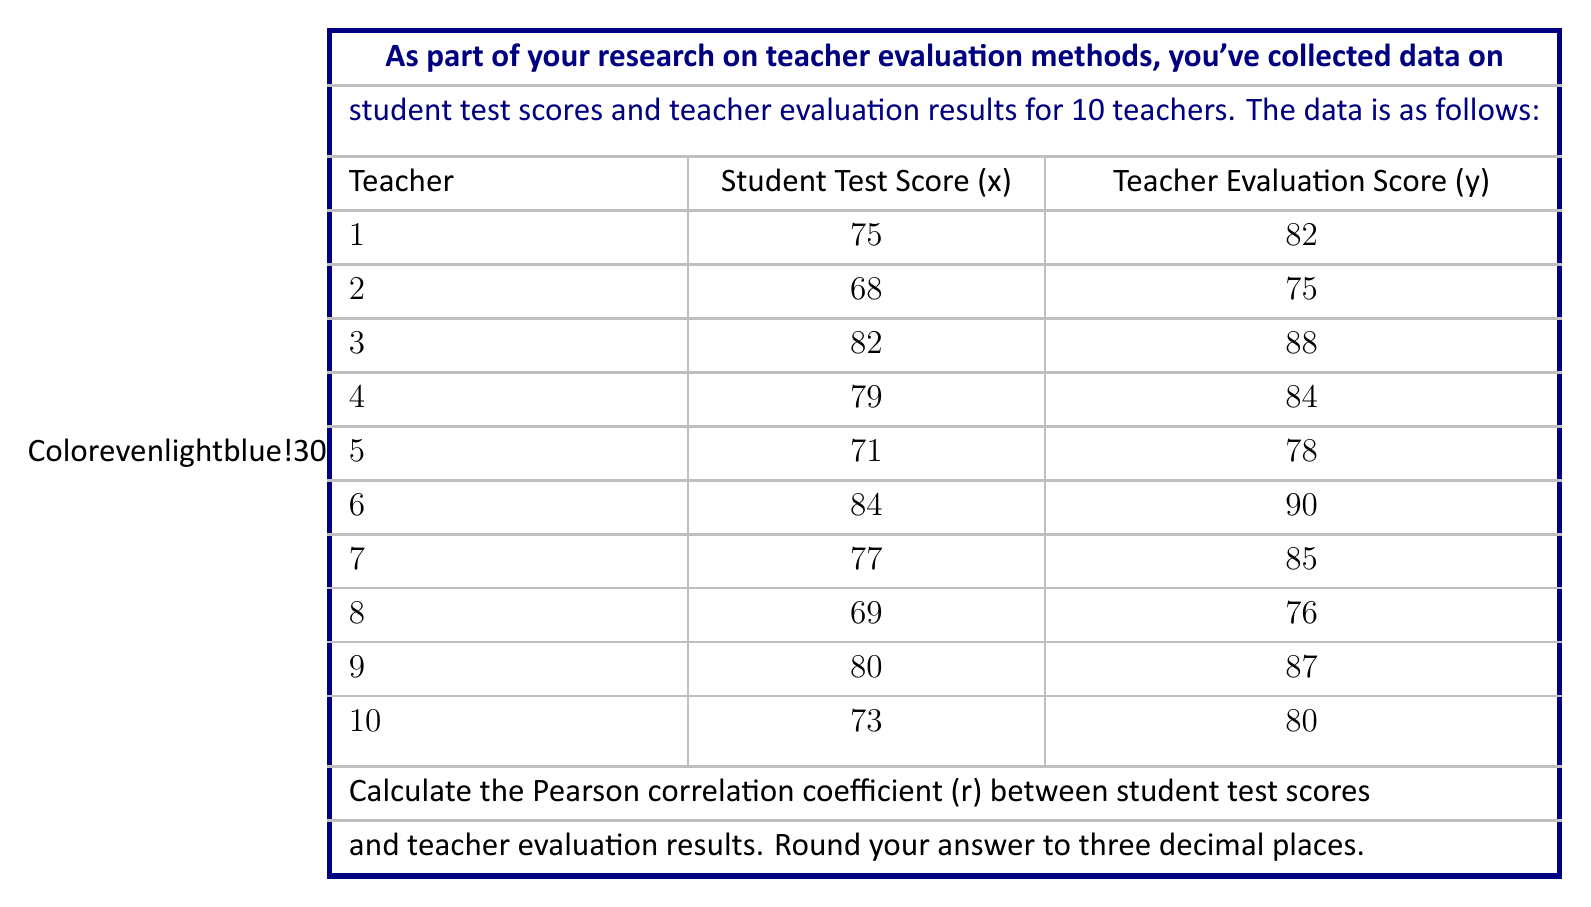Provide a solution to this math problem. To calculate the Pearson correlation coefficient (r), we'll follow these steps:

1. Calculate the means of x and y:
   $$\bar{x} = \frac{\sum x}{n} = \frac{758}{10} = 75.8$$
   $$\bar{y} = \frac{\sum y}{n} = \frac{825}{10} = 82.5$$

2. Calculate the deviations from the mean for x and y:
   x - x̄ and y - ȳ for each pair

3. Calculate the products of the deviations:
   (x - x̄)(y - ȳ) for each pair

4. Sum the products of deviations:
   $$\sum (x - \bar{x})(y - \bar{y}) = 229.4$$

5. Calculate the sum of squared deviations for x and y:
   $$\sum (x - \bar{x})^2 = 308.4$$
   $$\sum (y - \bar{y})^2 = 258.5$$

6. Apply the formula for Pearson correlation coefficient:
   $$r = \frac{\sum (x - \bar{x})(y - \bar{y})}{\sqrt{\sum (x - \bar{x})^2 \sum (y - \bar{y})^2}}$$

   $$r = \frac{229.4}{\sqrt{308.4 \times 258.5}}$$

   $$r = \frac{229.4}{\sqrt{79,721.4}}$$

   $$r = \frac{229.4}{282.35}$$

   $$r \approx 0.812$$

Rounding to three decimal places, we get 0.812.
Answer: 0.812 